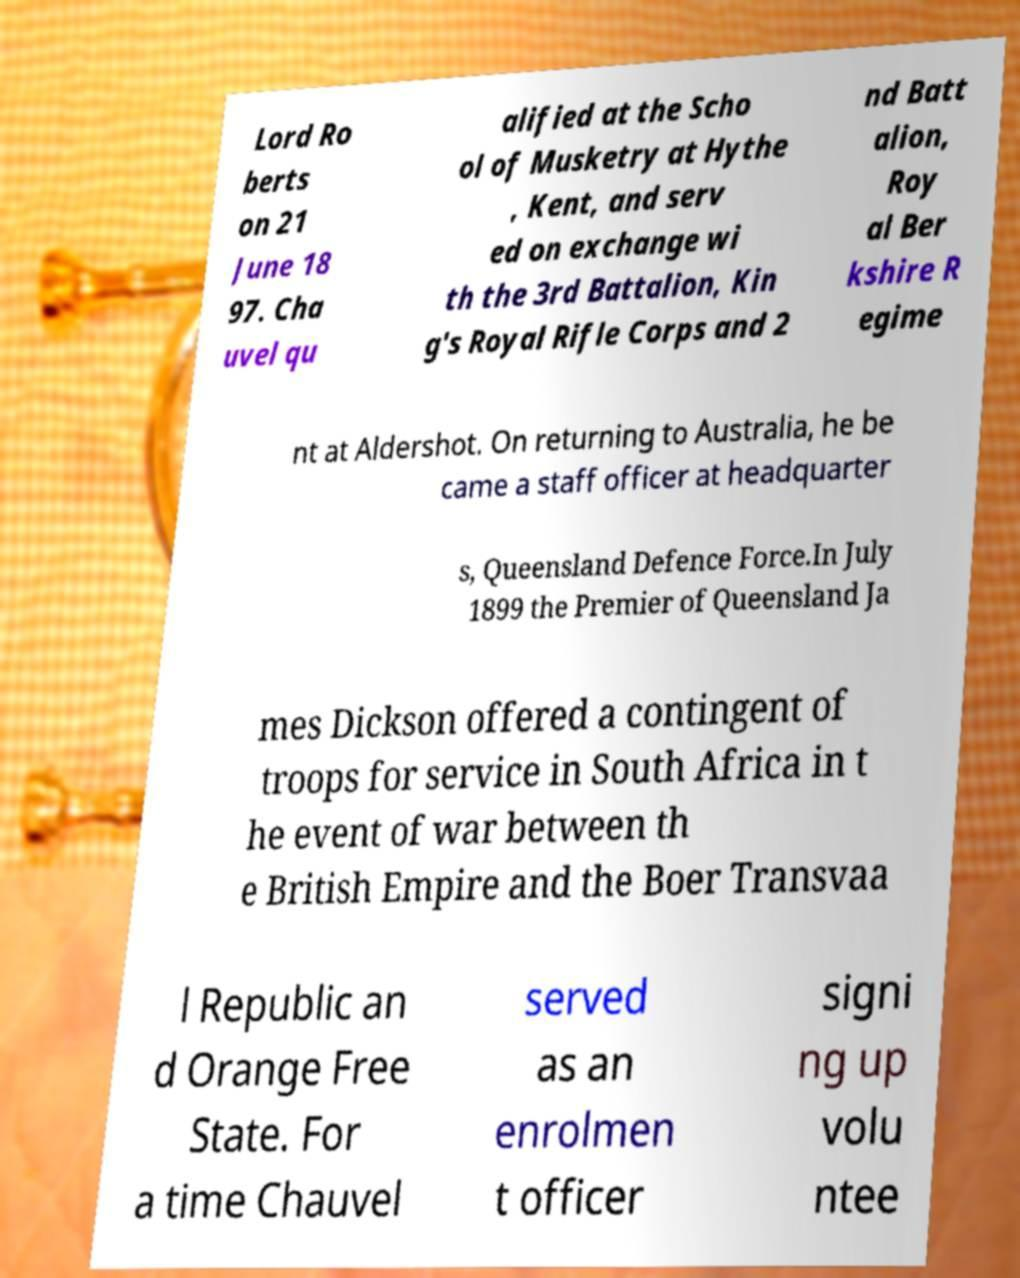There's text embedded in this image that I need extracted. Can you transcribe it verbatim? Lord Ro berts on 21 June 18 97. Cha uvel qu alified at the Scho ol of Musketry at Hythe , Kent, and serv ed on exchange wi th the 3rd Battalion, Kin g's Royal Rifle Corps and 2 nd Batt alion, Roy al Ber kshire R egime nt at Aldershot. On returning to Australia, he be came a staff officer at headquarter s, Queensland Defence Force.In July 1899 the Premier of Queensland Ja mes Dickson offered a contingent of troops for service in South Africa in t he event of war between th e British Empire and the Boer Transvaa l Republic an d Orange Free State. For a time Chauvel served as an enrolmen t officer signi ng up volu ntee 